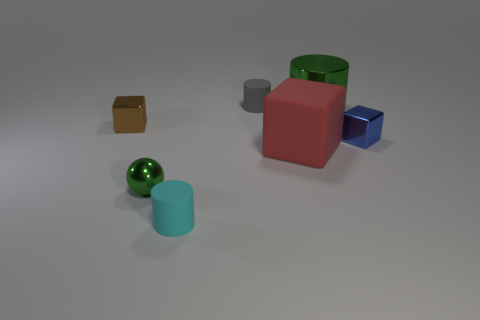What number of other objects are there of the same material as the blue thing?
Offer a terse response. 3. The small blue thing that is made of the same material as the large green object is what shape?
Offer a terse response. Cube. Is there any other thing that is the same color as the large cylinder?
Provide a succinct answer. Yes. The metallic sphere that is the same color as the big shiny object is what size?
Your response must be concise. Small. Is the number of small rubber objects in front of the small blue metallic thing greater than the number of large gray cylinders?
Make the answer very short. Yes. Does the big red thing have the same shape as the tiny metallic object that is right of the red rubber object?
Your response must be concise. Yes. What number of other blocks are the same size as the red cube?
Provide a succinct answer. 0. There is a green object that is left of the matte object that is behind the big green shiny object; how many tiny metal blocks are to the left of it?
Offer a terse response. 1. Are there an equal number of small brown objects that are in front of the red object and small matte cylinders that are behind the cyan cylinder?
Make the answer very short. No. What number of cyan metallic objects have the same shape as the cyan matte object?
Offer a very short reply. 0. 